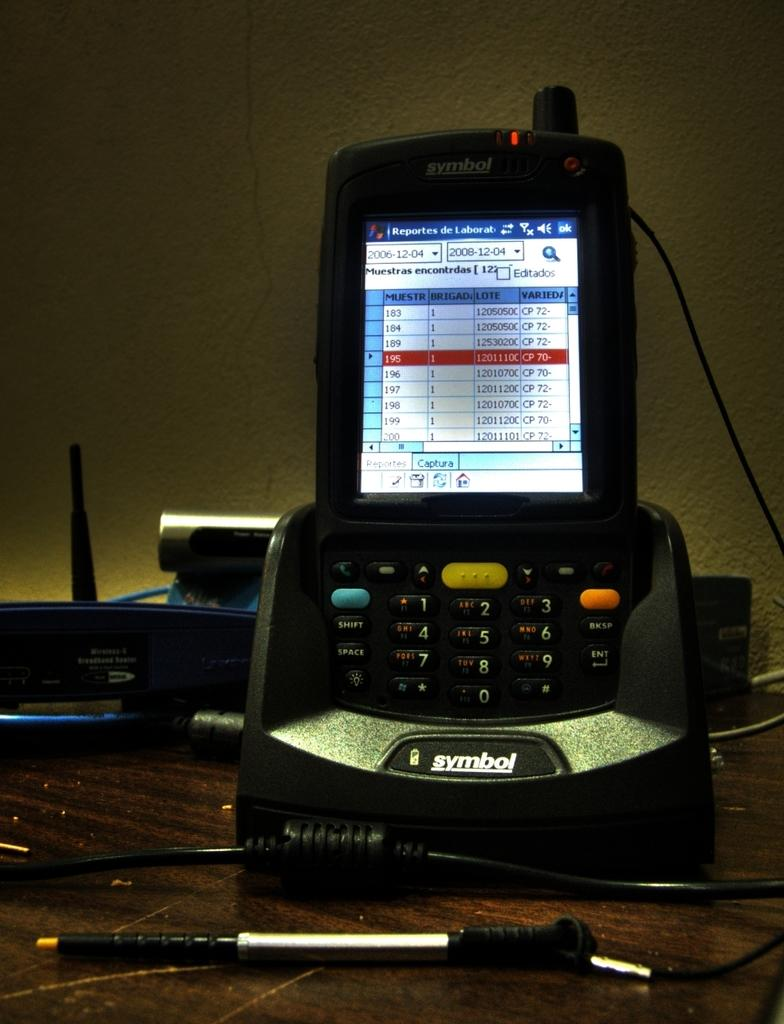<image>
Relay a brief, clear account of the picture shown. The numbers 1 through 9 are displayed on buttons on a cell phone. 